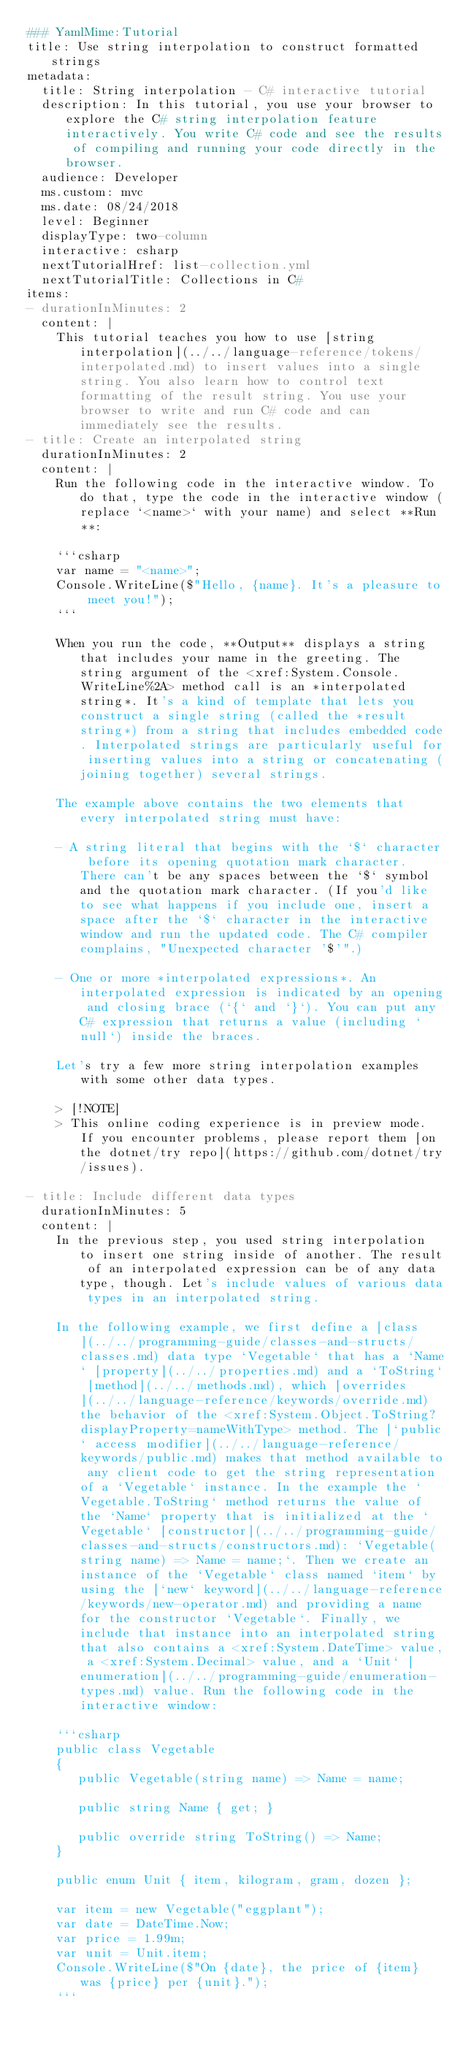Convert code to text. <code><loc_0><loc_0><loc_500><loc_500><_YAML_>### YamlMime:Tutorial
title: Use string interpolation to construct formatted strings 
metadata:
  title: String interpolation - C# interactive tutorial 
  description: In this tutorial, you use your browser to explore the C# string interpolation feature interactively. You write C# code and see the results of compiling and running your code directly in the browser.
  audience: Developer
  ms.custom: mvc
  ms.date: 08/24/2018
  level: Beginner
  displayType: two-column
  interactive: csharp
  nextTutorialHref: list-collection.yml
  nextTutorialTitle: Collections in C#
items:
- durationInMinutes: 2
  content: |
    This tutorial teaches you how to use [string interpolation](../../language-reference/tokens/interpolated.md) to insert values into a single string. You also learn how to control text formatting of the result string. You use your browser to write and run C# code and can immediately see the results.
- title: Create an interpolated string
  durationInMinutes: 2
  content: |
    Run the following code in the interactive window. To do that, type the code in the interactive window (replace `<name>` with your name) and select **Run**:

    ```csharp
    var name = "<name>";
    Console.WriteLine($"Hello, {name}. It's a pleasure to meet you!");
    ```

    When you run the code, **Output** displays a string that includes your name in the greeting. The string argument of the <xref:System.Console.WriteLine%2A> method call is an *interpolated string*. It's a kind of template that lets you construct a single string (called the *result string*) from a string that includes embedded code. Interpolated strings are particularly useful for inserting values into a string or concatenating (joining together) several strings. 
    
    The example above contains the two elements that every interpolated string must have: 

    - A string literal that begins with the `$` character before its opening quotation mark character. There can't be any spaces between the `$` symbol and the quotation mark character. (If you'd like to see what happens if you include one, insert a space after the `$` character in the interactive window and run the updated code. The C# compiler complains, "Unexpected character '$'".) 

    - One or more *interpolated expressions*. An interpolated expression is indicated by an opening and closing brace (`{` and `}`). You can put any C# expression that returns a value (including `null`) inside the braces. 

    Let's try a few more string interpolation examples with some other data types.
    
    > [!NOTE]
    > This online coding experience is in preview mode. If you encounter problems, please report them [on the dotnet/try repo](https://github.com/dotnet/try/issues).

- title: Include different data types
  durationInMinutes: 5
  content: |
    In the previous step, you used string interpolation to insert one string inside of another. The result of an interpolated expression can be of any data type, though. Let's include values of various data types in an interpolated string. 
    
    In the following example, we first define a [class](../../programming-guide/classes-and-structs/classes.md) data type `Vegetable` that has a `Name` [property](../../properties.md) and a `ToString` [method](../../methods.md), which [overrides](../../language-reference/keywords/override.md) the behavior of the <xref:System.Object.ToString?displayProperty=nameWithType> method. The [`public` access modifier](../../language-reference/keywords/public.md) makes that method available to any client code to get the string representation of a `Vegetable` instance. In the example the `Vegetable.ToString` method returns the value of the `Name` property that is initialized at the `Vegetable` [constructor](../../programming-guide/classes-and-structs/constructors.md): `Vegetable(string name) => Name = name;`. Then we create an instance of the `Vegetable` class named `item` by using the [`new` keyword](../../language-reference/keywords/new-operator.md) and providing a name for the constructor `Vegetable`. Finally, we include that instance into an interpolated string that also contains a <xref:System.DateTime> value, a <xref:System.Decimal> value, and a `Unit` [enumeration](../../programming-guide/enumeration-types.md) value. Run the following code in the interactive window:

    ```csharp
    public class Vegetable
    {
       public Vegetable(string name) => Name = name;
    
       public string Name { get; }
   
       public override string ToString() => Name;
    }

    public enum Unit { item, kilogram, gram, dozen };

    var item = new Vegetable("eggplant");
    var date = DateTime.Now;
    var price = 1.99m;
    var unit = Unit.item;
    Console.WriteLine($"On {date}, the price of {item} was {price} per {unit}.");
    ```
    </code> 